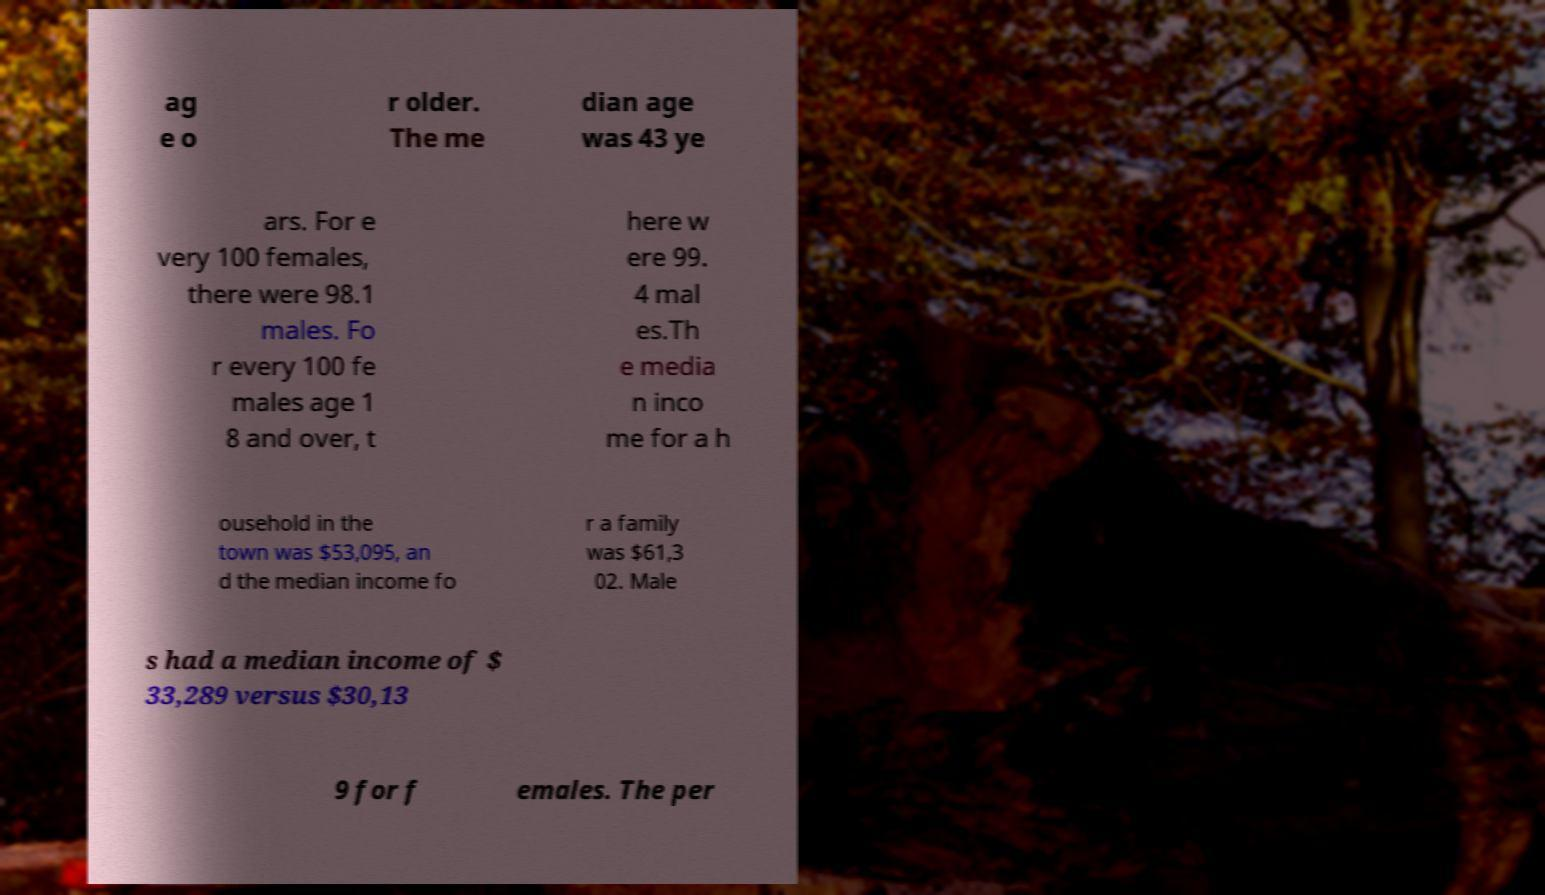What messages or text are displayed in this image? I need them in a readable, typed format. ag e o r older. The me dian age was 43 ye ars. For e very 100 females, there were 98.1 males. Fo r every 100 fe males age 1 8 and over, t here w ere 99. 4 mal es.Th e media n inco me for a h ousehold in the town was $53,095, an d the median income fo r a family was $61,3 02. Male s had a median income of $ 33,289 versus $30,13 9 for f emales. The per 